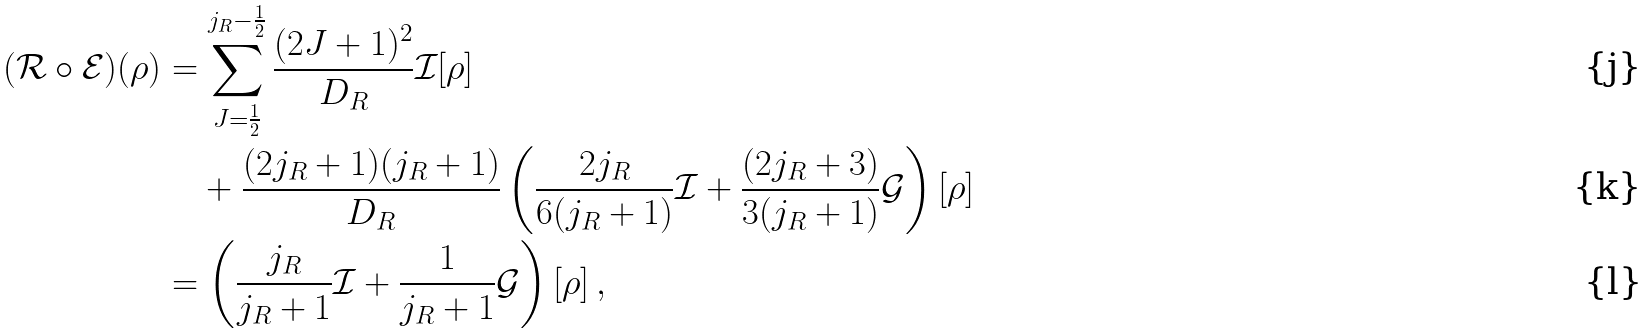<formula> <loc_0><loc_0><loc_500><loc_500>( \mathcal { R } \circ \mathcal { E } ) ( \rho ) & = \sum _ { J = \frac { 1 } { 2 } } ^ { j _ { R } - \frac { 1 } { 2 } } \frac { ( 2 J + 1 ) ^ { 2 } } { D _ { R } } \mathcal { I } [ \rho ] \\ & \quad + \frac { ( 2 j _ { R } + 1 ) ( j _ { R } + 1 ) } { D _ { R } } \left ( \frac { 2 j _ { R } } { 6 ( { j _ { R } } + 1 ) } \mathcal { I } + \frac { ( 2 j _ { R } + 3 ) } { 3 ( { j _ { R } } + 1 ) } \mathcal { G } \right ) [ \rho ] \\ & = \left ( \frac { j _ { R } } { { j _ { R } } + 1 } \mathcal { I } + \frac { 1 } { { j _ { R } } + 1 } \mathcal { G } \right ) [ \rho ] \, ,</formula> 